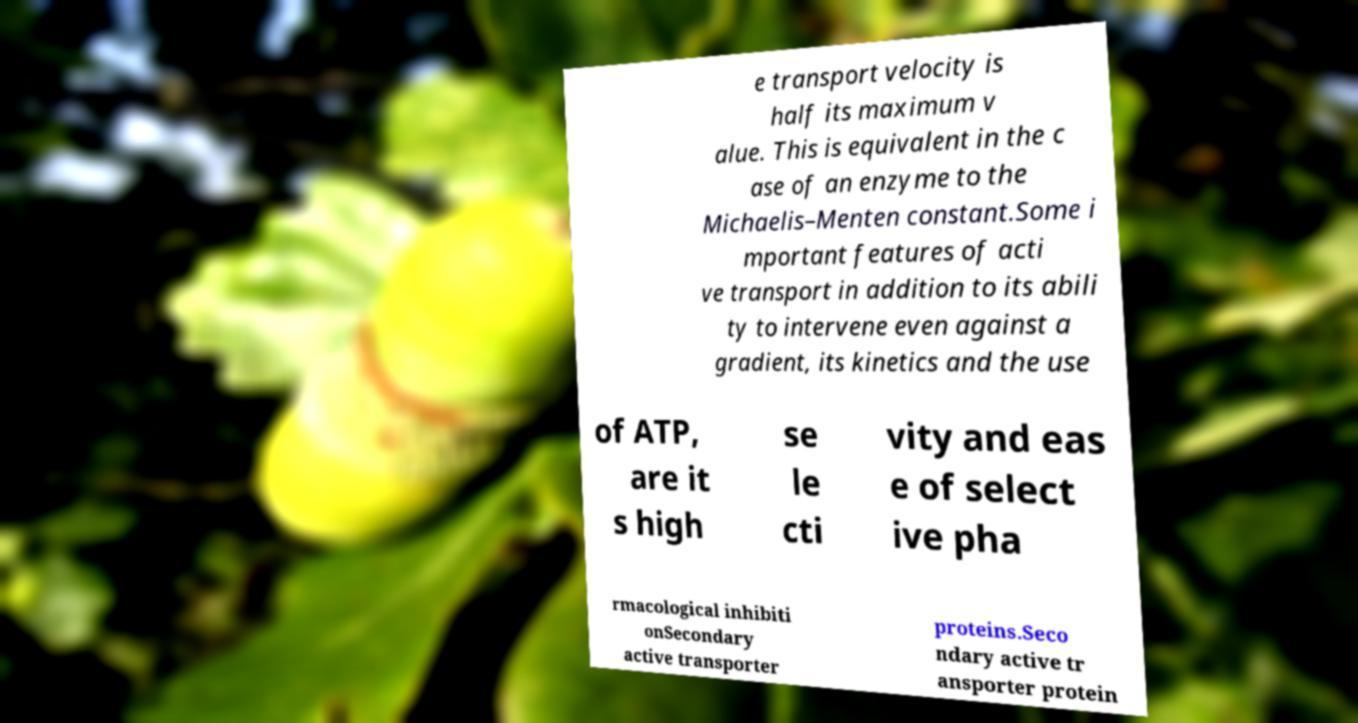Please identify and transcribe the text found in this image. e transport velocity is half its maximum v alue. This is equivalent in the c ase of an enzyme to the Michaelis–Menten constant.Some i mportant features of acti ve transport in addition to its abili ty to intervene even against a gradient, its kinetics and the use of ATP, are it s high se le cti vity and eas e of select ive pha rmacological inhibiti onSecondary active transporter proteins.Seco ndary active tr ansporter protein 